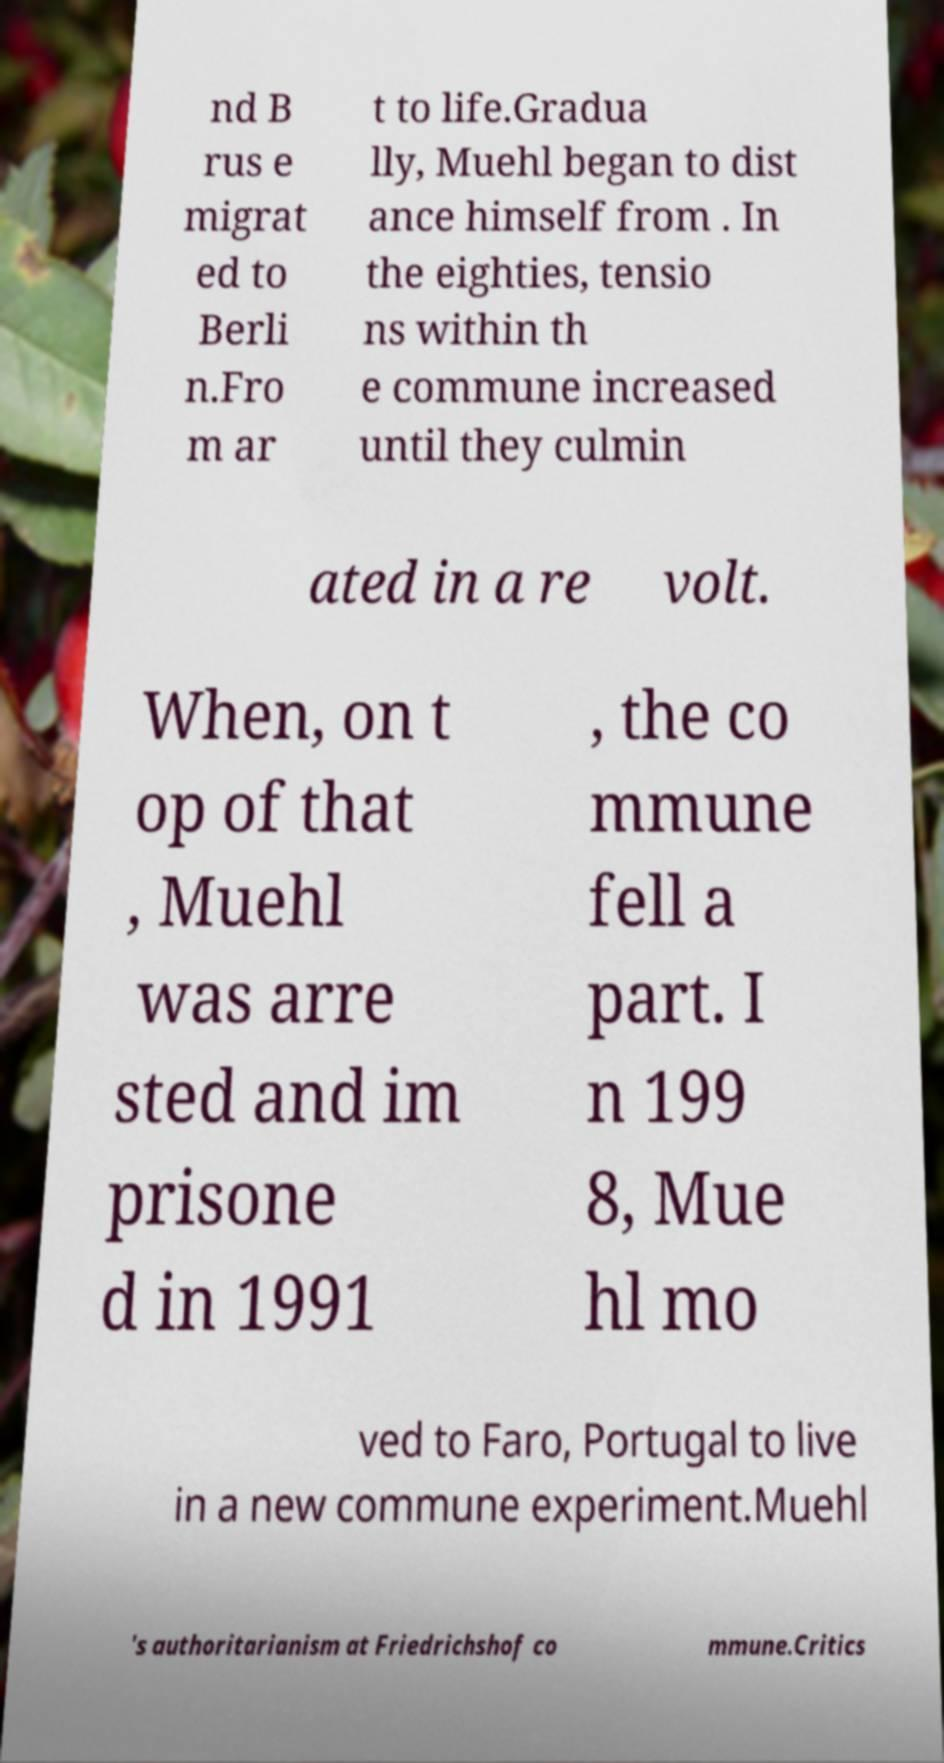I need the written content from this picture converted into text. Can you do that? nd B rus e migrat ed to Berli n.Fro m ar t to life.Gradua lly, Muehl began to dist ance himself from . In the eighties, tensio ns within th e commune increased until they culmin ated in a re volt. When, on t op of that , Muehl was arre sted and im prisone d in 1991 , the co mmune fell a part. I n 199 8, Mue hl mo ved to Faro, Portugal to live in a new commune experiment.Muehl 's authoritarianism at Friedrichshof co mmune.Critics 